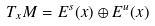<formula> <loc_0><loc_0><loc_500><loc_500>T _ { x } M = E ^ { s } ( x ) \oplus E ^ { u } ( x )</formula> 